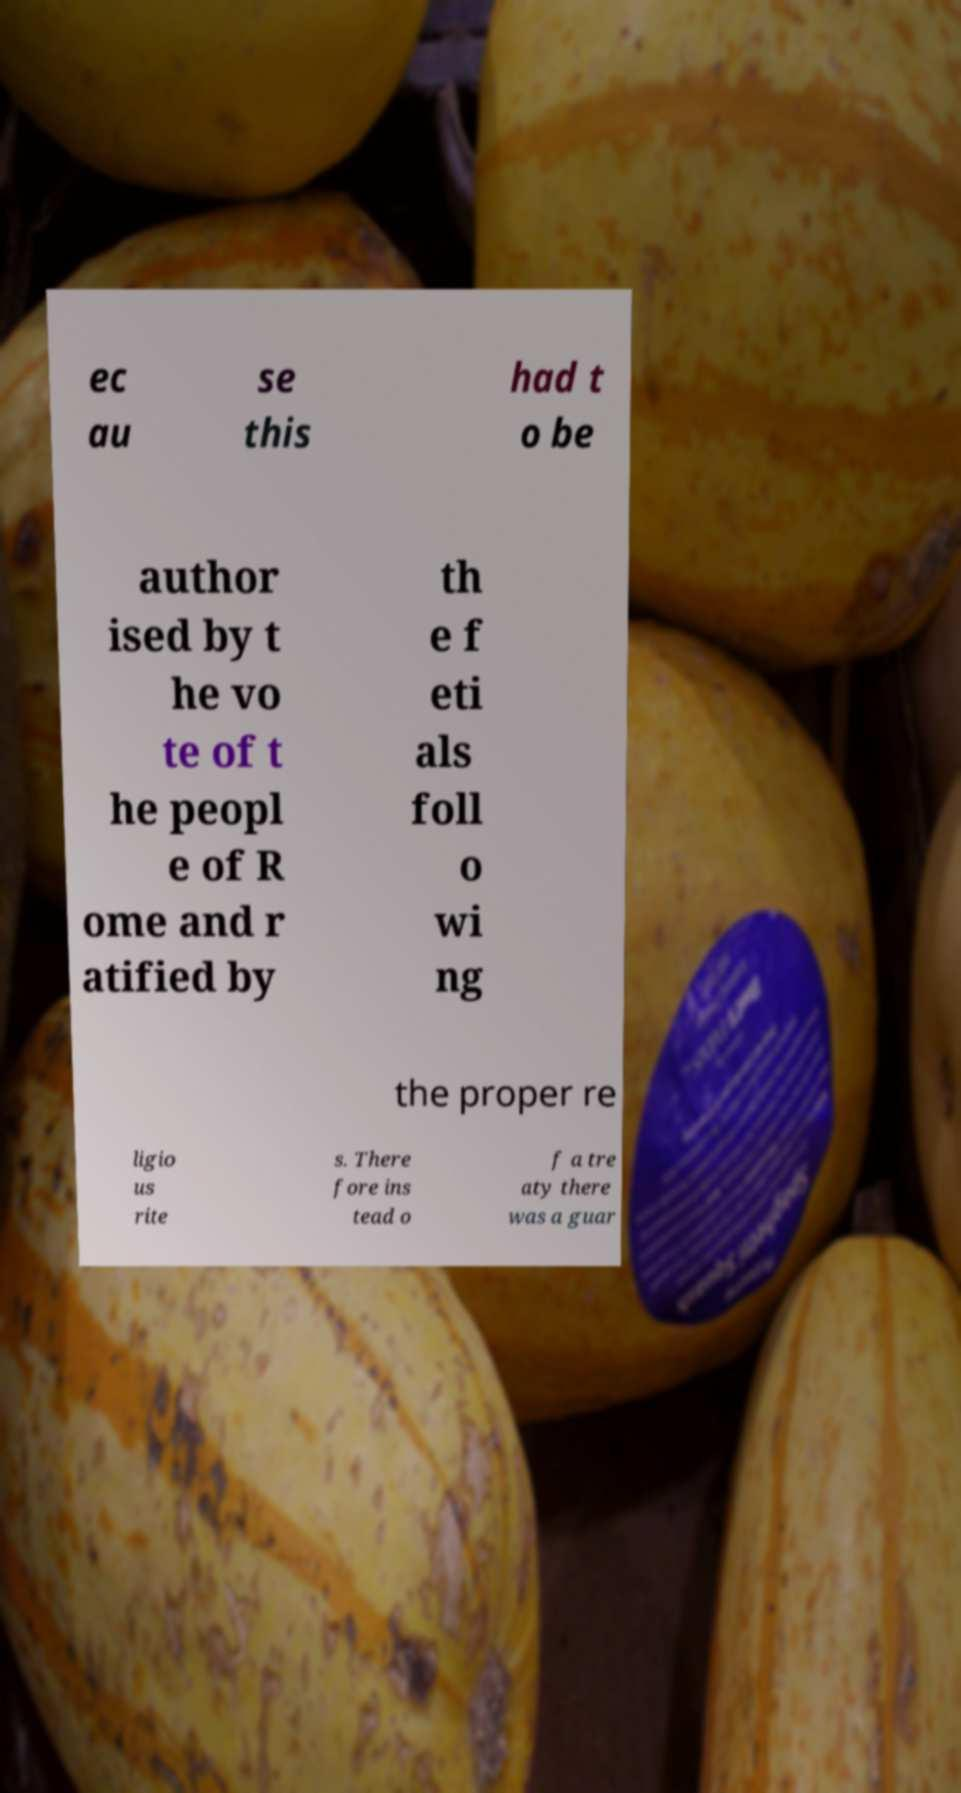Please read and relay the text visible in this image. What does it say? ec au se this had t o be author ised by t he vo te of t he peopl e of R ome and r atified by th e f eti als foll o wi ng the proper re ligio us rite s. There fore ins tead o f a tre aty there was a guar 